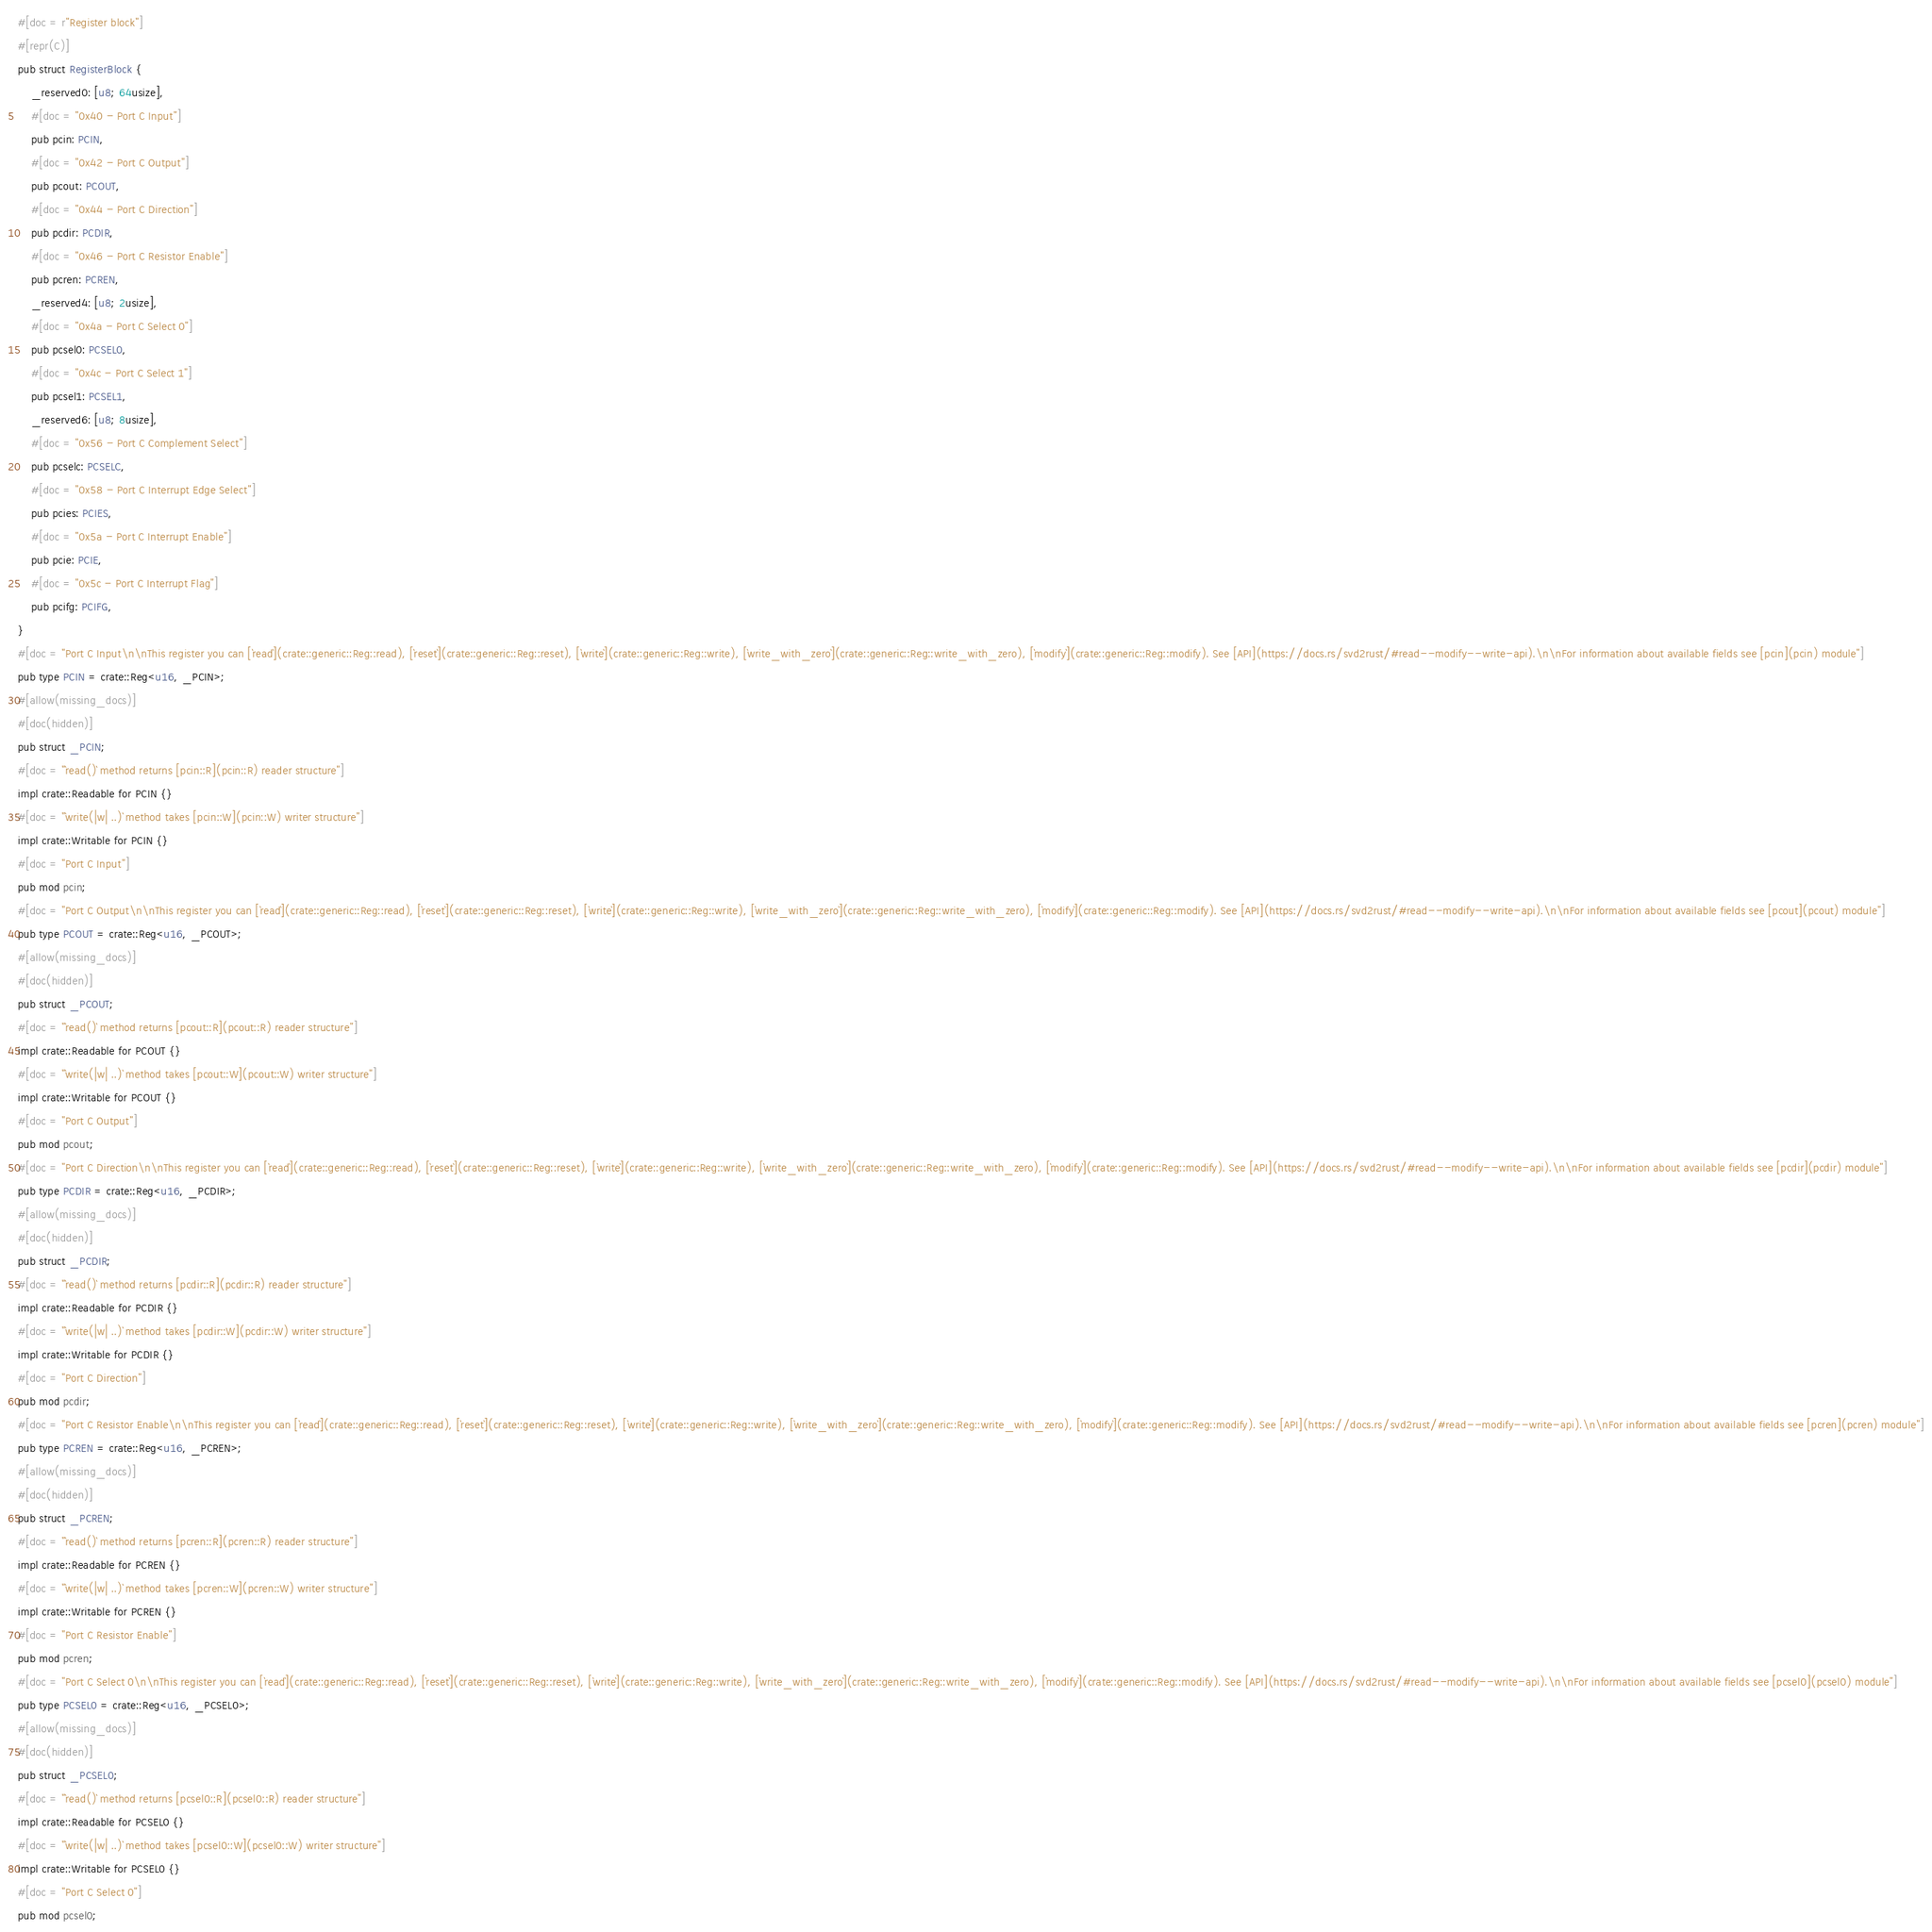Convert code to text. <code><loc_0><loc_0><loc_500><loc_500><_Rust_>#[doc = r"Register block"]
#[repr(C)]
pub struct RegisterBlock {
    _reserved0: [u8; 64usize],
    #[doc = "0x40 - Port C Input"]
    pub pcin: PCIN,
    #[doc = "0x42 - Port C Output"]
    pub pcout: PCOUT,
    #[doc = "0x44 - Port C Direction"]
    pub pcdir: PCDIR,
    #[doc = "0x46 - Port C Resistor Enable"]
    pub pcren: PCREN,
    _reserved4: [u8; 2usize],
    #[doc = "0x4a - Port C Select 0"]
    pub pcsel0: PCSEL0,
    #[doc = "0x4c - Port C Select 1"]
    pub pcsel1: PCSEL1,
    _reserved6: [u8; 8usize],
    #[doc = "0x56 - Port C Complement Select"]
    pub pcselc: PCSELC,
    #[doc = "0x58 - Port C Interrupt Edge Select"]
    pub pcies: PCIES,
    #[doc = "0x5a - Port C Interrupt Enable"]
    pub pcie: PCIE,
    #[doc = "0x5c - Port C Interrupt Flag"]
    pub pcifg: PCIFG,
}
#[doc = "Port C Input\n\nThis register you can [`read`](crate::generic::Reg::read), [`reset`](crate::generic::Reg::reset), [`write`](crate::generic::Reg::write), [`write_with_zero`](crate::generic::Reg::write_with_zero), [`modify`](crate::generic::Reg::modify). See [API](https://docs.rs/svd2rust/#read--modify--write-api).\n\nFor information about available fields see [pcin](pcin) module"]
pub type PCIN = crate::Reg<u16, _PCIN>;
#[allow(missing_docs)]
#[doc(hidden)]
pub struct _PCIN;
#[doc = "`read()` method returns [pcin::R](pcin::R) reader structure"]
impl crate::Readable for PCIN {}
#[doc = "`write(|w| ..)` method takes [pcin::W](pcin::W) writer structure"]
impl crate::Writable for PCIN {}
#[doc = "Port C Input"]
pub mod pcin;
#[doc = "Port C Output\n\nThis register you can [`read`](crate::generic::Reg::read), [`reset`](crate::generic::Reg::reset), [`write`](crate::generic::Reg::write), [`write_with_zero`](crate::generic::Reg::write_with_zero), [`modify`](crate::generic::Reg::modify). See [API](https://docs.rs/svd2rust/#read--modify--write-api).\n\nFor information about available fields see [pcout](pcout) module"]
pub type PCOUT = crate::Reg<u16, _PCOUT>;
#[allow(missing_docs)]
#[doc(hidden)]
pub struct _PCOUT;
#[doc = "`read()` method returns [pcout::R](pcout::R) reader structure"]
impl crate::Readable for PCOUT {}
#[doc = "`write(|w| ..)` method takes [pcout::W](pcout::W) writer structure"]
impl crate::Writable for PCOUT {}
#[doc = "Port C Output"]
pub mod pcout;
#[doc = "Port C Direction\n\nThis register you can [`read`](crate::generic::Reg::read), [`reset`](crate::generic::Reg::reset), [`write`](crate::generic::Reg::write), [`write_with_zero`](crate::generic::Reg::write_with_zero), [`modify`](crate::generic::Reg::modify). See [API](https://docs.rs/svd2rust/#read--modify--write-api).\n\nFor information about available fields see [pcdir](pcdir) module"]
pub type PCDIR = crate::Reg<u16, _PCDIR>;
#[allow(missing_docs)]
#[doc(hidden)]
pub struct _PCDIR;
#[doc = "`read()` method returns [pcdir::R](pcdir::R) reader structure"]
impl crate::Readable for PCDIR {}
#[doc = "`write(|w| ..)` method takes [pcdir::W](pcdir::W) writer structure"]
impl crate::Writable for PCDIR {}
#[doc = "Port C Direction"]
pub mod pcdir;
#[doc = "Port C Resistor Enable\n\nThis register you can [`read`](crate::generic::Reg::read), [`reset`](crate::generic::Reg::reset), [`write`](crate::generic::Reg::write), [`write_with_zero`](crate::generic::Reg::write_with_zero), [`modify`](crate::generic::Reg::modify). See [API](https://docs.rs/svd2rust/#read--modify--write-api).\n\nFor information about available fields see [pcren](pcren) module"]
pub type PCREN = crate::Reg<u16, _PCREN>;
#[allow(missing_docs)]
#[doc(hidden)]
pub struct _PCREN;
#[doc = "`read()` method returns [pcren::R](pcren::R) reader structure"]
impl crate::Readable for PCREN {}
#[doc = "`write(|w| ..)` method takes [pcren::W](pcren::W) writer structure"]
impl crate::Writable for PCREN {}
#[doc = "Port C Resistor Enable"]
pub mod pcren;
#[doc = "Port C Select 0\n\nThis register you can [`read`](crate::generic::Reg::read), [`reset`](crate::generic::Reg::reset), [`write`](crate::generic::Reg::write), [`write_with_zero`](crate::generic::Reg::write_with_zero), [`modify`](crate::generic::Reg::modify). See [API](https://docs.rs/svd2rust/#read--modify--write-api).\n\nFor information about available fields see [pcsel0](pcsel0) module"]
pub type PCSEL0 = crate::Reg<u16, _PCSEL0>;
#[allow(missing_docs)]
#[doc(hidden)]
pub struct _PCSEL0;
#[doc = "`read()` method returns [pcsel0::R](pcsel0::R) reader structure"]
impl crate::Readable for PCSEL0 {}
#[doc = "`write(|w| ..)` method takes [pcsel0::W](pcsel0::W) writer structure"]
impl crate::Writable for PCSEL0 {}
#[doc = "Port C Select 0"]
pub mod pcsel0;</code> 